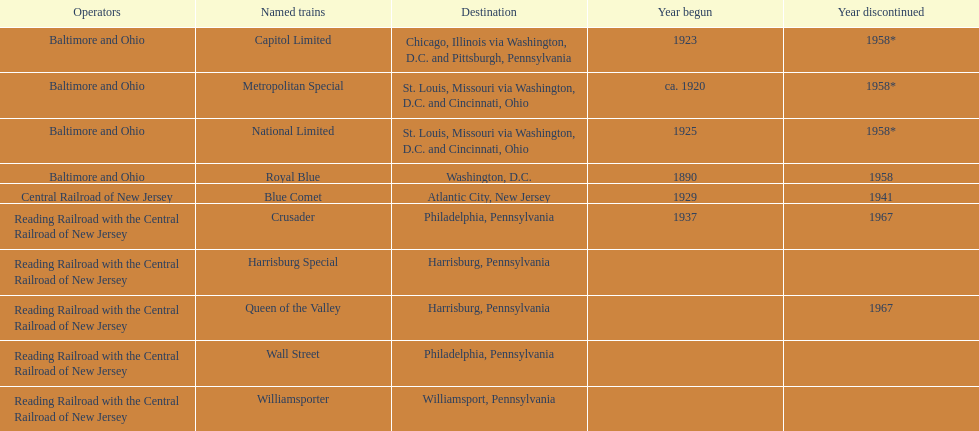What operators manage the reading railroad and the central railroad of new jersey? Reading Railroad with the Central Railroad of New Jersey, Reading Railroad with the Central Railroad of New Jersey, Reading Railroad with the Central Railroad of New Jersey, Reading Railroad with the Central Railroad of New Jersey, Reading Railroad with the Central Railroad of New Jersey. What are the destinations in philadelphia, pennsylvania? Philadelphia, Pennsylvania, Philadelphia, Pennsylvania. What commenced in 1937? 1937. What is the train called? Crusader. 